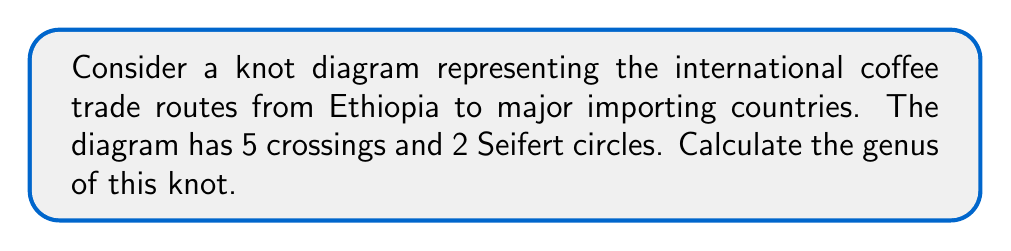Teach me how to tackle this problem. To calculate the genus of a knot diagram, we'll follow these steps:

1. Recall the formula for genus:
   $$g = \frac{1}{2}(c - s + 1)$$
   where $g$ is the genus, $c$ is the number of crossings, and $s$ is the number of Seifert circles.

2. Given information:
   - Number of crossings (c) = 5
   - Number of Seifert circles (s) = 2

3. Substitute the values into the formula:
   $$g = \frac{1}{2}(5 - 2 + 1)$$

4. Simplify:
   $$g = \frac{1}{2}(4)$$

5. Calculate the final result:
   $$g = 2$$

This genus value represents the complexity of the coffee trade routes, reflecting the intricate nature of international coffee export processes that an attentive officer would need to navigate.
Answer: $2$ 